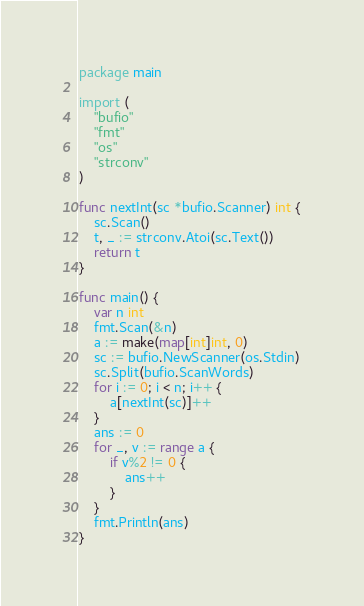<code> <loc_0><loc_0><loc_500><loc_500><_Go_>package main

import (
	"bufio"
	"fmt"
	"os"
	"strconv"
)

func nextInt(sc *bufio.Scanner) int {
	sc.Scan()
	t, _ := strconv.Atoi(sc.Text())
	return t
}

func main() {
	var n int
	fmt.Scan(&n)
	a := make(map[int]int, 0)
	sc := bufio.NewScanner(os.Stdin)
	sc.Split(bufio.ScanWords)
	for i := 0; i < n; i++ {
		a[nextInt(sc)]++
	}
	ans := 0
	for _, v := range a {
		if v%2 != 0 {
			ans++
		}
	}
	fmt.Println(ans)
}
</code> 